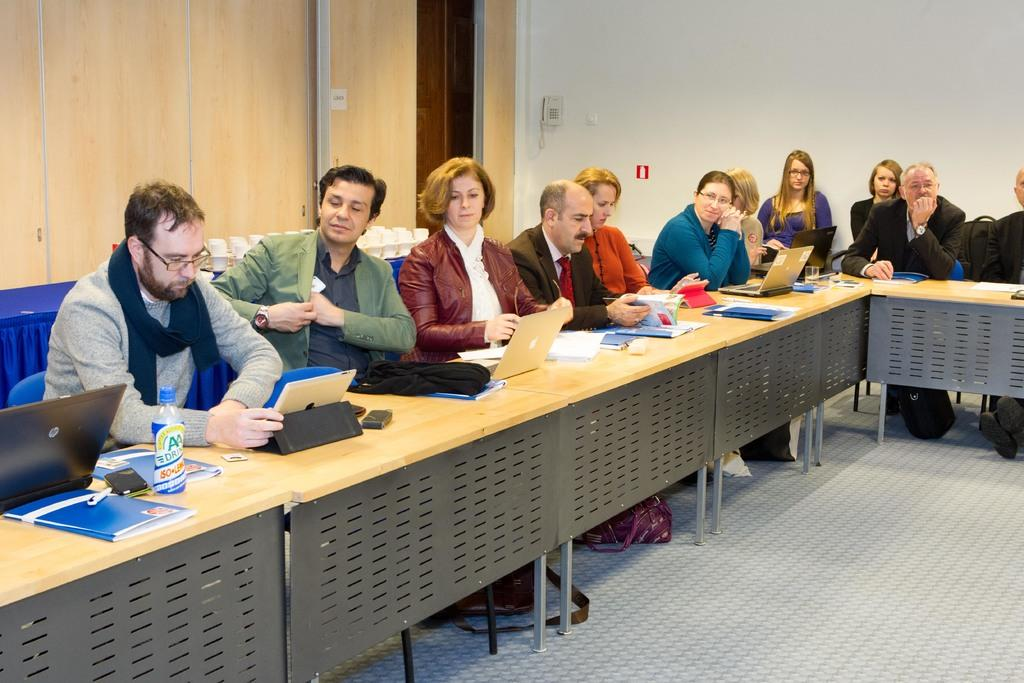How many people are in the image? There is a group of people in the image. What are the people doing in the image? The people are seated on chairs. What objects can be seen on the table in the image? There are laptops, papers, and bottles on the table. What type of cactus is present in the image? There is no cactus present in the image. What is the weather like in the image? The provided facts do not mention the weather, so we cannot determine the weather from the image. 